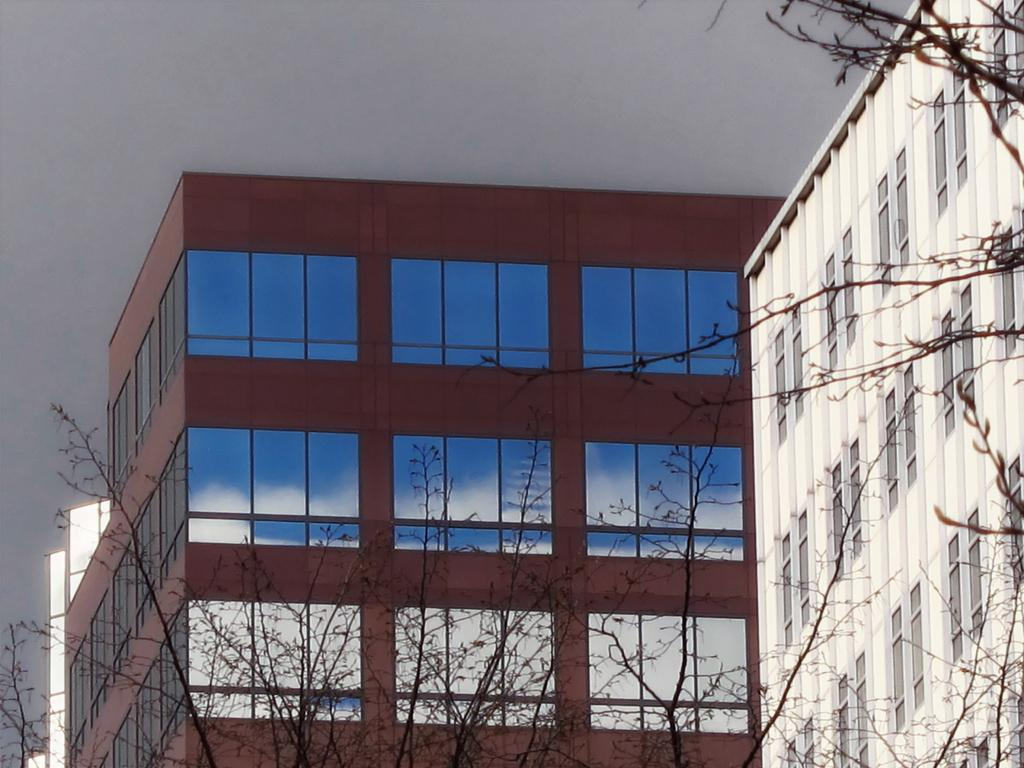What type of structures can be seen in the image? There are buildings in the image. What objects are present on a surface in the image? There are glasses in the image. What type of vegetation is visible in the image? There are trees in the image. What is visible in the background of the image? The sky is visible in the background of the image. Can you hear the acoustics of the rat running through the image? There is no rat present in the image, so it is not possible to hear any acoustics related to a rat. 